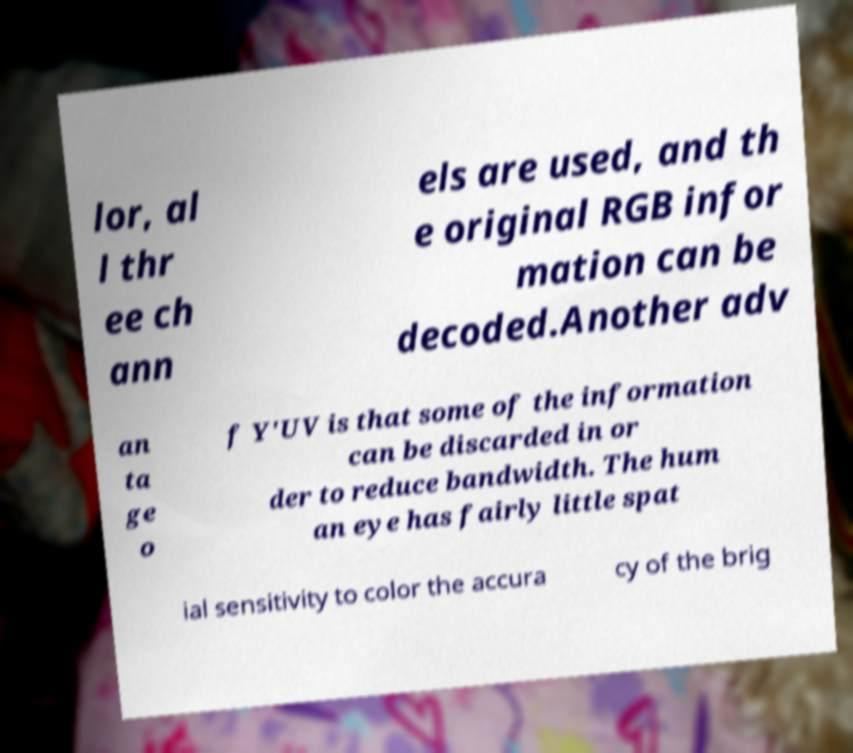Could you assist in decoding the text presented in this image and type it out clearly? lor, al l thr ee ch ann els are used, and th e original RGB infor mation can be decoded.Another adv an ta ge o f Y′UV is that some of the information can be discarded in or der to reduce bandwidth. The hum an eye has fairly little spat ial sensitivity to color the accura cy of the brig 